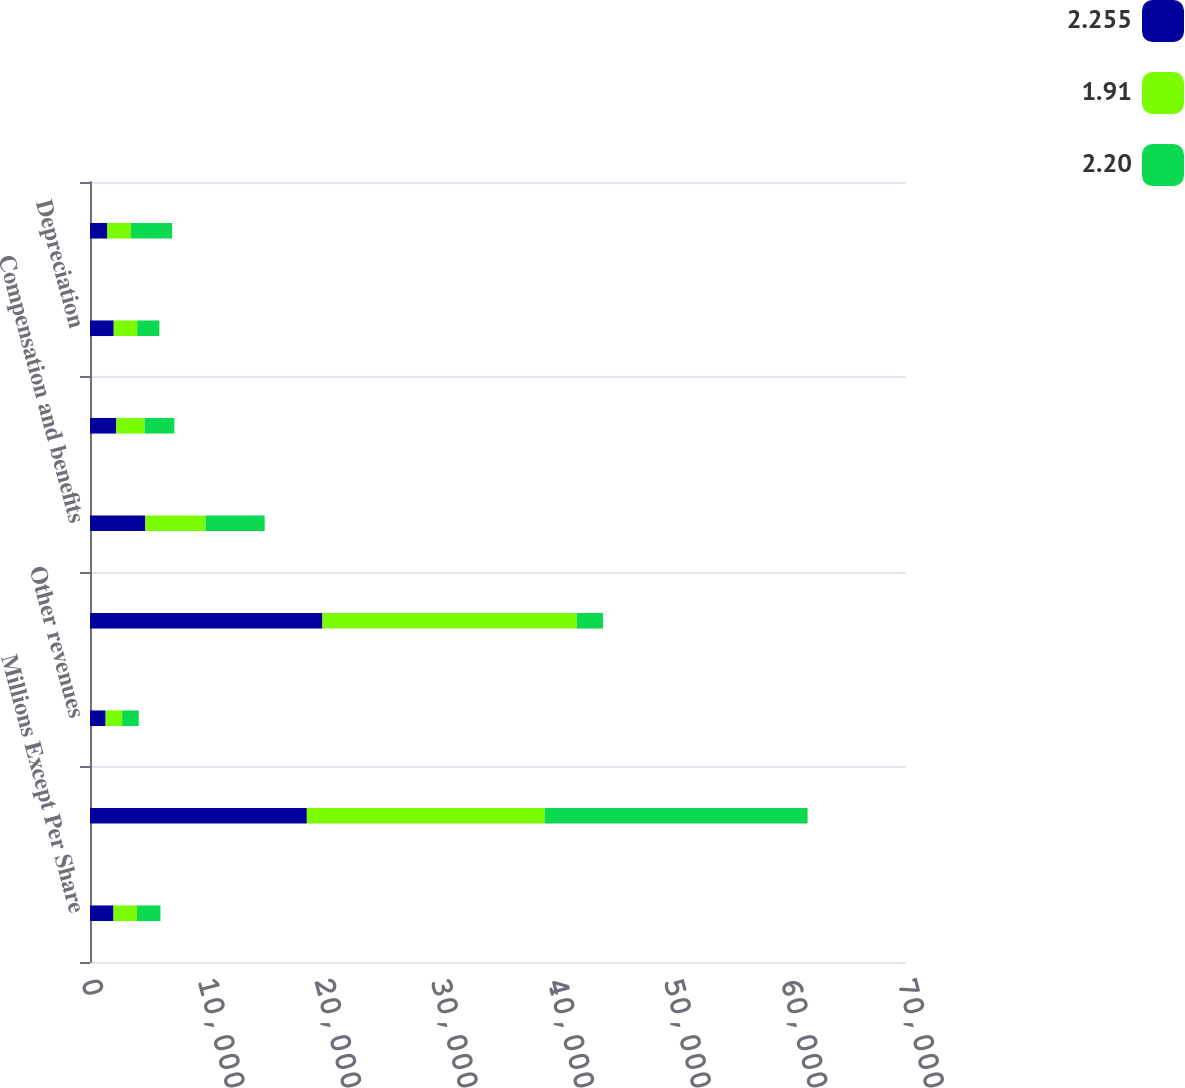<chart> <loc_0><loc_0><loc_500><loc_500><stacked_bar_chart><ecel><fcel>Millions Except Per Share<fcel>Freight revenues<fcel>Other revenues<fcel>Total operating revenues<fcel>Compensation and benefits<fcel>Purchased services and<fcel>Depreciation<fcel>Fuel<nl><fcel>2.255<fcel>2016<fcel>18601<fcel>1340<fcel>19941<fcel>4750<fcel>2258<fcel>2038<fcel>1489<nl><fcel>1.91<fcel>2015<fcel>20397<fcel>1416<fcel>21813<fcel>5161<fcel>2421<fcel>2012<fcel>2013<nl><fcel>2.2<fcel>2014<fcel>22560<fcel>1428<fcel>2258<fcel>5076<fcel>2558<fcel>1904<fcel>3539<nl></chart> 